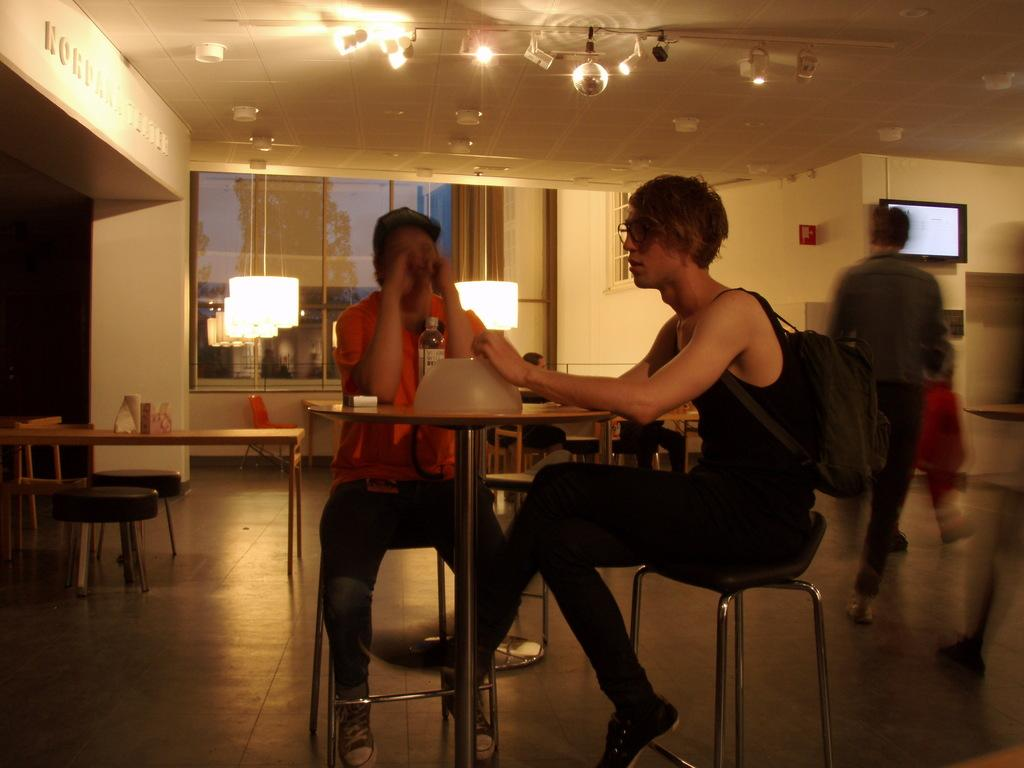How many people are sitting on the chair in the image? There are two persons sitting on a chair in the image. What is located in front of the chair? The two persons are in front of a table. What is the man in the image doing? There is a man walking on the floor in the image. What type of hat is the man wearing in the image? There is no hat present in the image; the man is walking on the floor without a hat. 